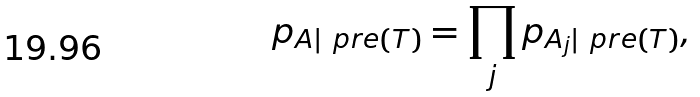<formula> <loc_0><loc_0><loc_500><loc_500>p _ { A | \ p r e ( T ) } = \prod _ { j } p _ { A _ { j } | \ p r e ( T ) } ,</formula> 